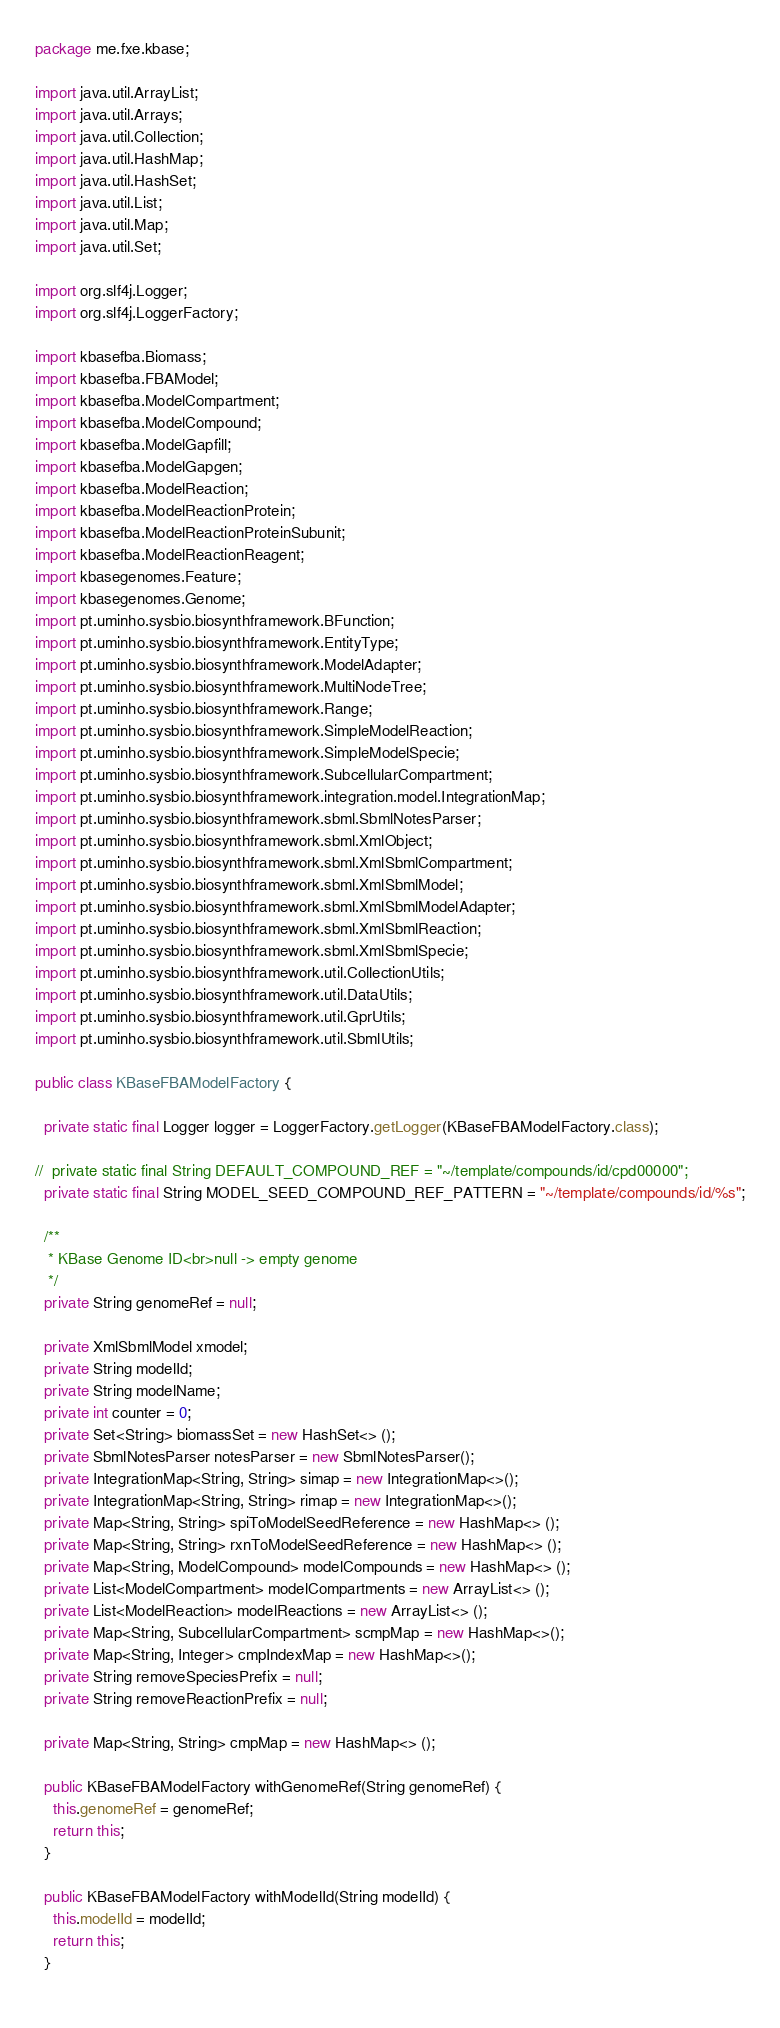Convert code to text. <code><loc_0><loc_0><loc_500><loc_500><_Java_>package me.fxe.kbase;

import java.util.ArrayList;
import java.util.Arrays;
import java.util.Collection;
import java.util.HashMap;
import java.util.HashSet;
import java.util.List;
import java.util.Map;
import java.util.Set;

import org.slf4j.Logger;
import org.slf4j.LoggerFactory;

import kbasefba.Biomass;
import kbasefba.FBAModel;
import kbasefba.ModelCompartment;
import kbasefba.ModelCompound;
import kbasefba.ModelGapfill;
import kbasefba.ModelGapgen;
import kbasefba.ModelReaction;
import kbasefba.ModelReactionProtein;
import kbasefba.ModelReactionProteinSubunit;
import kbasefba.ModelReactionReagent;
import kbasegenomes.Feature;
import kbasegenomes.Genome;
import pt.uminho.sysbio.biosynthframework.BFunction;
import pt.uminho.sysbio.biosynthframework.EntityType;
import pt.uminho.sysbio.biosynthframework.ModelAdapter;
import pt.uminho.sysbio.biosynthframework.MultiNodeTree;
import pt.uminho.sysbio.biosynthframework.Range;
import pt.uminho.sysbio.biosynthframework.SimpleModelReaction;
import pt.uminho.sysbio.biosynthframework.SimpleModelSpecie;
import pt.uminho.sysbio.biosynthframework.SubcellularCompartment;
import pt.uminho.sysbio.biosynthframework.integration.model.IntegrationMap;
import pt.uminho.sysbio.biosynthframework.sbml.SbmlNotesParser;
import pt.uminho.sysbio.biosynthframework.sbml.XmlObject;
import pt.uminho.sysbio.biosynthframework.sbml.XmlSbmlCompartment;
import pt.uminho.sysbio.biosynthframework.sbml.XmlSbmlModel;
import pt.uminho.sysbio.biosynthframework.sbml.XmlSbmlModelAdapter;
import pt.uminho.sysbio.biosynthframework.sbml.XmlSbmlReaction;
import pt.uminho.sysbio.biosynthframework.sbml.XmlSbmlSpecie;
import pt.uminho.sysbio.biosynthframework.util.CollectionUtils;
import pt.uminho.sysbio.biosynthframework.util.DataUtils;
import pt.uminho.sysbio.biosynthframework.util.GprUtils;
import pt.uminho.sysbio.biosynthframework.util.SbmlUtils;

public class KBaseFBAModelFactory {

  private static final Logger logger = LoggerFactory.getLogger(KBaseFBAModelFactory.class);
  
//  private static final String DEFAULT_COMPOUND_REF = "~/template/compounds/id/cpd00000";
  private static final String MODEL_SEED_COMPOUND_REF_PATTERN = "~/template/compounds/id/%s";
  
  /**
   * KBase Genome ID<br>null -> empty genome
   */
  private String genomeRef = null;
  
  private XmlSbmlModel xmodel;
  private String modelId;
  private String modelName;
  private int counter = 0;
  private Set<String> biomassSet = new HashSet<> ();
  private SbmlNotesParser notesParser = new SbmlNotesParser();
  private IntegrationMap<String, String> simap = new IntegrationMap<>();
  private IntegrationMap<String, String> rimap = new IntegrationMap<>();
  private Map<String, String> spiToModelSeedReference = new HashMap<> ();
  private Map<String, String> rxnToModelSeedReference = new HashMap<> ();
  private Map<String, ModelCompound> modelCompounds = new HashMap<> ();
  private List<ModelCompartment> modelCompartments = new ArrayList<> ();
  private List<ModelReaction> modelReactions = new ArrayList<> ();
  private Map<String, SubcellularCompartment> scmpMap = new HashMap<>();
  private Map<String, Integer> cmpIndexMap = new HashMap<>();
  private String removeSpeciesPrefix = null;
  private String removeReactionPrefix = null;
  
  private Map<String, String> cmpMap = new HashMap<> ();
  
  public KBaseFBAModelFactory withGenomeRef(String genomeRef) {
    this.genomeRef = genomeRef;
    return this;
  }
  
  public KBaseFBAModelFactory withModelId(String modelId) {
    this.modelId = modelId;
    return this;
  }
  </code> 